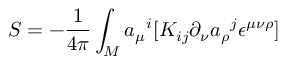Convert formula to latex. <formula><loc_0><loc_0><loc_500><loc_500>S = - { \frac { 1 } { 4 \pi } } \int _ { M } { a _ { \mu } } ^ { i } [ K _ { i j } \partial _ { \nu } { a _ { \rho } } ^ { j } \epsilon ^ { \mu \nu \rho } ]</formula> 